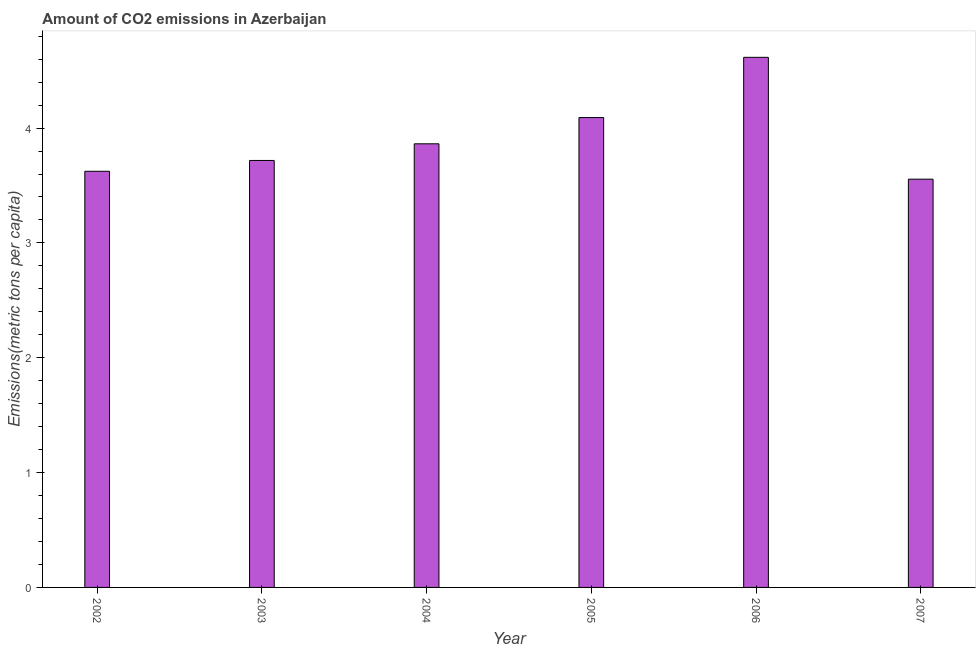Does the graph contain any zero values?
Your response must be concise. No. Does the graph contain grids?
Provide a short and direct response. No. What is the title of the graph?
Offer a terse response. Amount of CO2 emissions in Azerbaijan. What is the label or title of the X-axis?
Give a very brief answer. Year. What is the label or title of the Y-axis?
Offer a very short reply. Emissions(metric tons per capita). What is the amount of co2 emissions in 2002?
Provide a short and direct response. 3.62. Across all years, what is the maximum amount of co2 emissions?
Your answer should be compact. 4.62. Across all years, what is the minimum amount of co2 emissions?
Your answer should be compact. 3.56. In which year was the amount of co2 emissions maximum?
Give a very brief answer. 2006. What is the sum of the amount of co2 emissions?
Your answer should be very brief. 23.47. What is the difference between the amount of co2 emissions in 2004 and 2007?
Keep it short and to the point. 0.31. What is the average amount of co2 emissions per year?
Offer a very short reply. 3.91. What is the median amount of co2 emissions?
Give a very brief answer. 3.79. What is the ratio of the amount of co2 emissions in 2004 to that in 2006?
Make the answer very short. 0.84. Is the difference between the amount of co2 emissions in 2002 and 2007 greater than the difference between any two years?
Offer a very short reply. No. What is the difference between the highest and the second highest amount of co2 emissions?
Your response must be concise. 0.52. What is the difference between the highest and the lowest amount of co2 emissions?
Give a very brief answer. 1.06. In how many years, is the amount of co2 emissions greater than the average amount of co2 emissions taken over all years?
Ensure brevity in your answer.  2. What is the Emissions(metric tons per capita) in 2002?
Your answer should be compact. 3.62. What is the Emissions(metric tons per capita) of 2003?
Your answer should be compact. 3.72. What is the Emissions(metric tons per capita) in 2004?
Keep it short and to the point. 3.86. What is the Emissions(metric tons per capita) of 2005?
Provide a succinct answer. 4.09. What is the Emissions(metric tons per capita) in 2006?
Your answer should be compact. 4.62. What is the Emissions(metric tons per capita) in 2007?
Offer a very short reply. 3.56. What is the difference between the Emissions(metric tons per capita) in 2002 and 2003?
Offer a terse response. -0.09. What is the difference between the Emissions(metric tons per capita) in 2002 and 2004?
Give a very brief answer. -0.24. What is the difference between the Emissions(metric tons per capita) in 2002 and 2005?
Give a very brief answer. -0.47. What is the difference between the Emissions(metric tons per capita) in 2002 and 2006?
Your answer should be very brief. -0.99. What is the difference between the Emissions(metric tons per capita) in 2002 and 2007?
Offer a terse response. 0.07. What is the difference between the Emissions(metric tons per capita) in 2003 and 2004?
Make the answer very short. -0.15. What is the difference between the Emissions(metric tons per capita) in 2003 and 2005?
Provide a short and direct response. -0.37. What is the difference between the Emissions(metric tons per capita) in 2003 and 2006?
Offer a terse response. -0.9. What is the difference between the Emissions(metric tons per capita) in 2003 and 2007?
Provide a short and direct response. 0.16. What is the difference between the Emissions(metric tons per capita) in 2004 and 2005?
Your response must be concise. -0.23. What is the difference between the Emissions(metric tons per capita) in 2004 and 2006?
Make the answer very short. -0.75. What is the difference between the Emissions(metric tons per capita) in 2004 and 2007?
Provide a succinct answer. 0.31. What is the difference between the Emissions(metric tons per capita) in 2005 and 2006?
Offer a terse response. -0.52. What is the difference between the Emissions(metric tons per capita) in 2005 and 2007?
Your response must be concise. 0.54. What is the difference between the Emissions(metric tons per capita) in 2006 and 2007?
Give a very brief answer. 1.06. What is the ratio of the Emissions(metric tons per capita) in 2002 to that in 2004?
Provide a short and direct response. 0.94. What is the ratio of the Emissions(metric tons per capita) in 2002 to that in 2005?
Offer a very short reply. 0.89. What is the ratio of the Emissions(metric tons per capita) in 2002 to that in 2006?
Ensure brevity in your answer.  0.79. What is the ratio of the Emissions(metric tons per capita) in 2002 to that in 2007?
Give a very brief answer. 1.02. What is the ratio of the Emissions(metric tons per capita) in 2003 to that in 2005?
Provide a short and direct response. 0.91. What is the ratio of the Emissions(metric tons per capita) in 2003 to that in 2006?
Give a very brief answer. 0.81. What is the ratio of the Emissions(metric tons per capita) in 2003 to that in 2007?
Make the answer very short. 1.05. What is the ratio of the Emissions(metric tons per capita) in 2004 to that in 2005?
Provide a short and direct response. 0.94. What is the ratio of the Emissions(metric tons per capita) in 2004 to that in 2006?
Your answer should be compact. 0.84. What is the ratio of the Emissions(metric tons per capita) in 2004 to that in 2007?
Provide a short and direct response. 1.09. What is the ratio of the Emissions(metric tons per capita) in 2005 to that in 2006?
Provide a short and direct response. 0.89. What is the ratio of the Emissions(metric tons per capita) in 2005 to that in 2007?
Your answer should be very brief. 1.15. What is the ratio of the Emissions(metric tons per capita) in 2006 to that in 2007?
Ensure brevity in your answer.  1.3. 